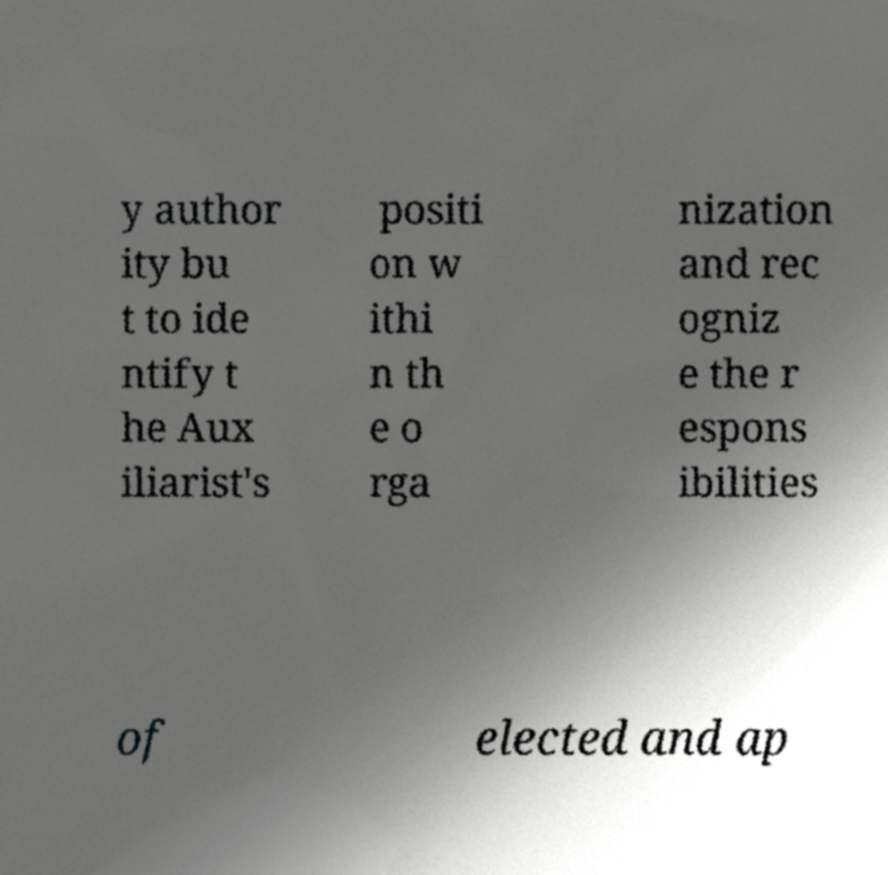What messages or text are displayed in this image? I need them in a readable, typed format. y author ity bu t to ide ntify t he Aux iliarist's positi on w ithi n th e o rga nization and rec ogniz e the r espons ibilities of elected and ap 